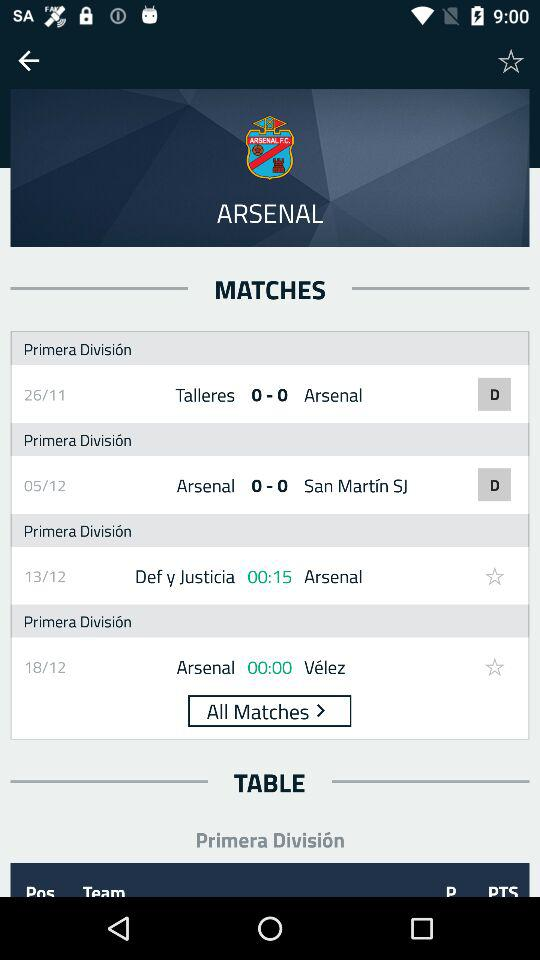How many matches are there in the Primera División league?
Answer the question using a single word or phrase. 4 